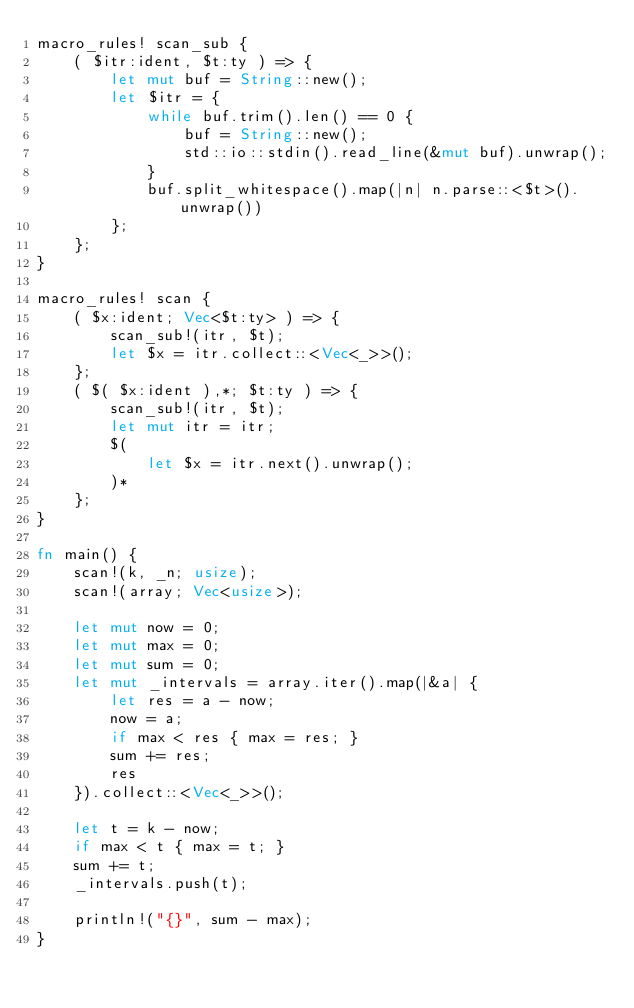Convert code to text. <code><loc_0><loc_0><loc_500><loc_500><_Rust_>macro_rules! scan_sub {
    ( $itr:ident, $t:ty ) => {
        let mut buf = String::new();
        let $itr = {
            while buf.trim().len() == 0 {
                buf = String::new();
                std::io::stdin().read_line(&mut buf).unwrap();
            }
            buf.split_whitespace().map(|n| n.parse::<$t>().unwrap())
        };
    };
}

macro_rules! scan {
    ( $x:ident; Vec<$t:ty> ) => {
        scan_sub!(itr, $t);
        let $x = itr.collect::<Vec<_>>();
    };
    ( $( $x:ident ),*; $t:ty ) => {
        scan_sub!(itr, $t);
        let mut itr = itr;
        $(
            let $x = itr.next().unwrap();
        )*
    };
}

fn main() {
    scan!(k, _n; usize);
    scan!(array; Vec<usize>);

    let mut now = 0;
    let mut max = 0;
    let mut sum = 0;
    let mut _intervals = array.iter().map(|&a| {
        let res = a - now;
        now = a;
        if max < res { max = res; }
        sum += res;
        res
    }).collect::<Vec<_>>();

    let t = k - now;
    if max < t { max = t; }
    sum += t;
    _intervals.push(t);

    println!("{}", sum - max);
}
</code> 